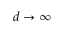<formula> <loc_0><loc_0><loc_500><loc_500>d \to \infty</formula> 